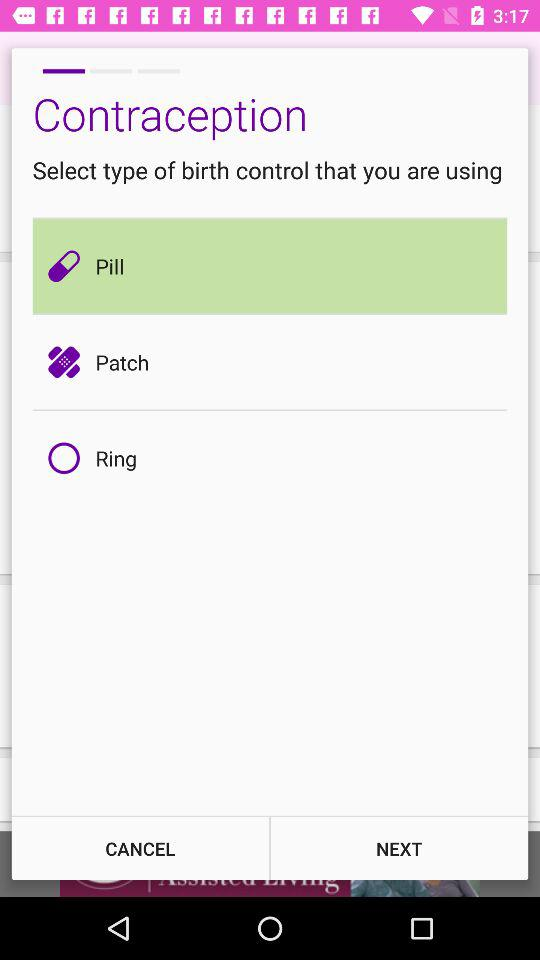What options are there for the birth control that I am using? The options that you are using for the birth control are "Pill", "Patch" and "Ring". 